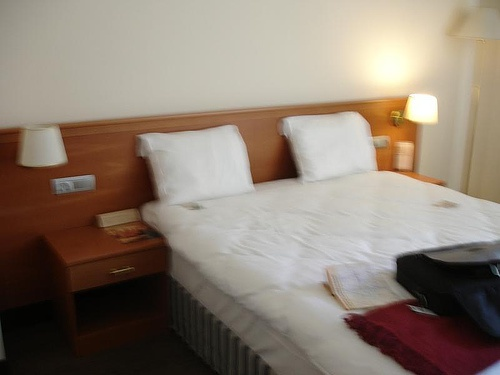Describe the objects in this image and their specific colors. I can see bed in gray, darkgray, lightgray, and black tones and suitcase in gray and black tones in this image. 